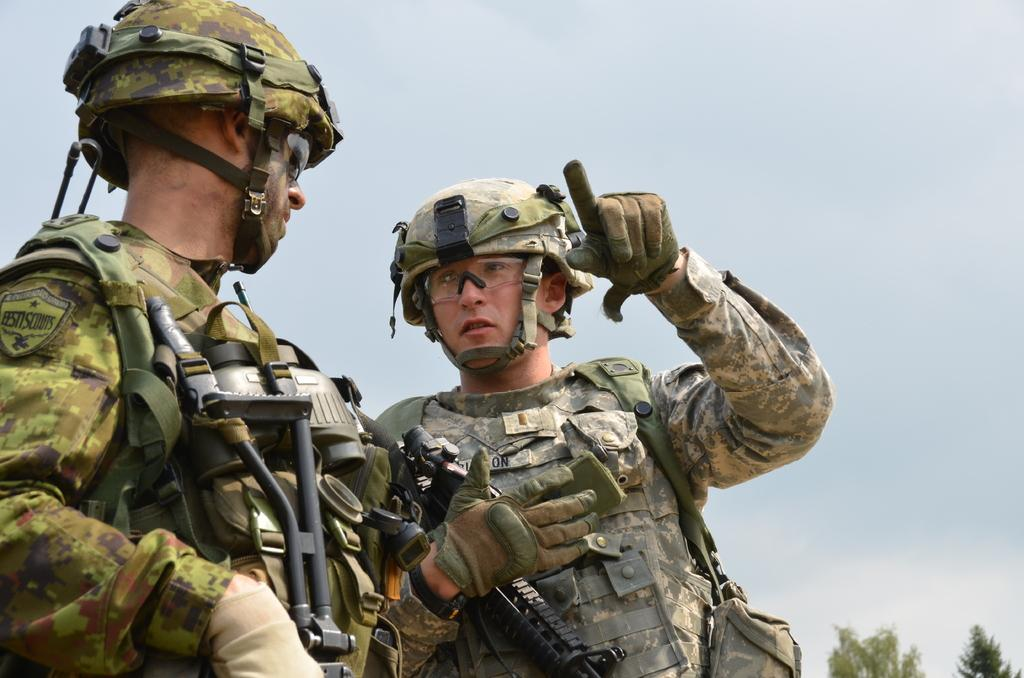How many people are in the image? There are two men in the image. What are the men holding in the image? The men are holding guns in the image. What else are the men carrying in the image? The men are carrying bags in the image. What protective gear are the men wearing in the image? The men are wearing helmets and gloves in the image. What can be seen in the background of the image? There are trees and the sky visible in the background of the image. What type of beetle can be seen crawling on the gloves of one of the men in the image? There is no beetle present on the gloves or anywhere else in the image. How many tomatoes are being carried by the men in the image? The men are not carrying any tomatoes in the image; they are carrying bags. 